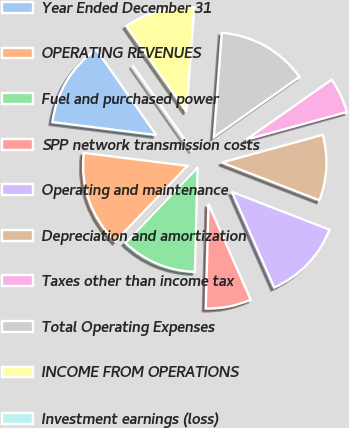Convert chart to OTSL. <chart><loc_0><loc_0><loc_500><loc_500><pie_chart><fcel>Year Ended December 31<fcel>OPERATING REVENUES<fcel>Fuel and purchased power<fcel>SPP network transmission costs<fcel>Operating and maintenance<fcel>Depreciation and amortization<fcel>Taxes other than income tax<fcel>Total Operating Expenses<fcel>INCOME FROM OPERATIONS<fcel>Investment earnings (loss)<nl><fcel>13.28%<fcel>14.84%<fcel>11.72%<fcel>7.03%<fcel>12.5%<fcel>10.16%<fcel>5.47%<fcel>14.06%<fcel>10.94%<fcel>0.0%<nl></chart> 